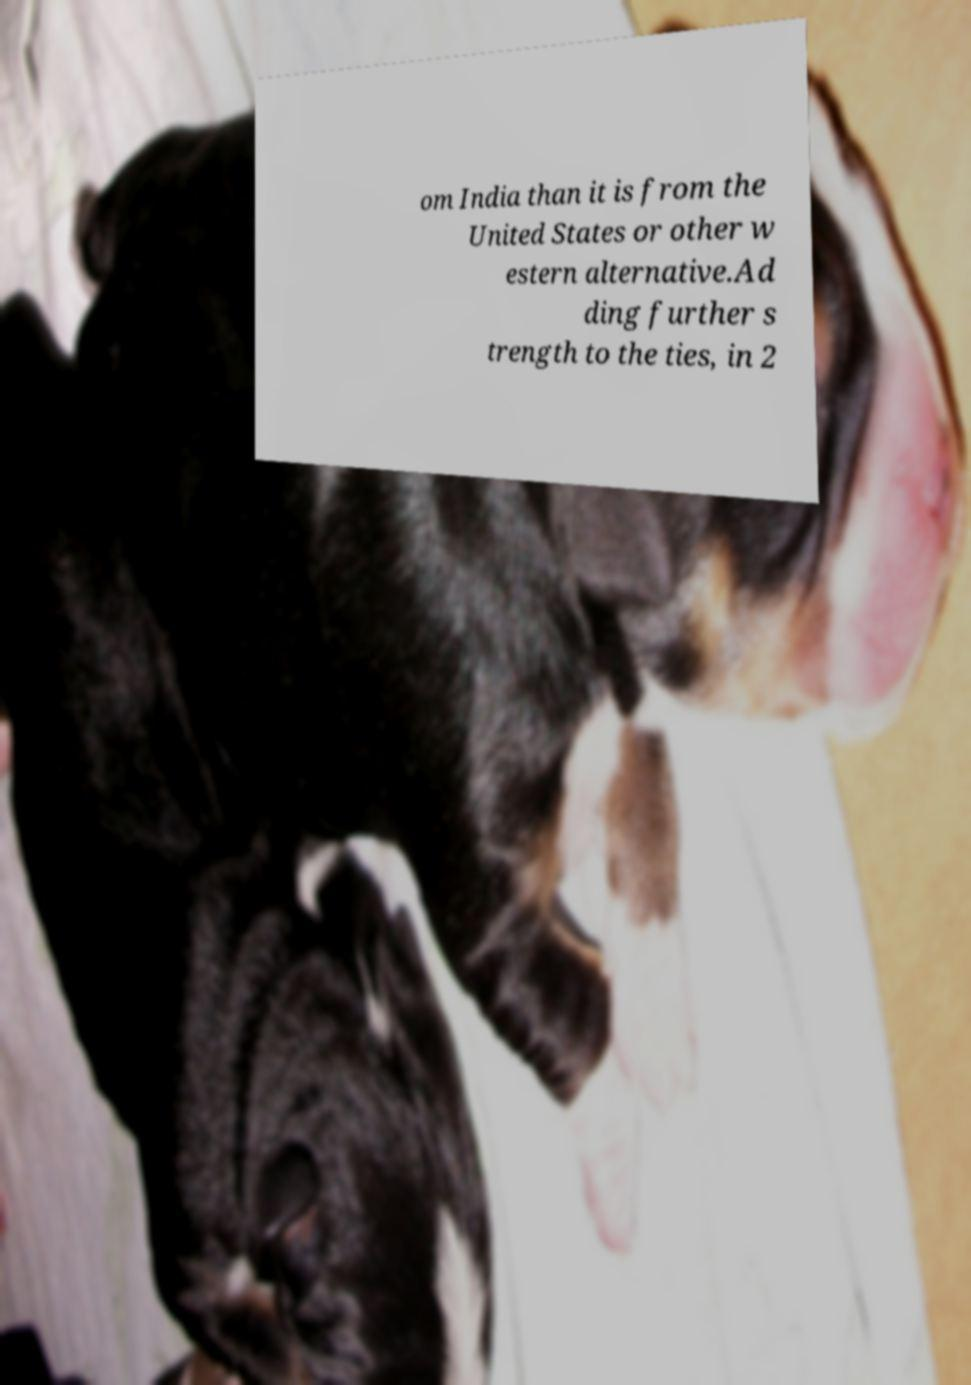Can you read and provide the text displayed in the image?This photo seems to have some interesting text. Can you extract and type it out for me? om India than it is from the United States or other w estern alternative.Ad ding further s trength to the ties, in 2 